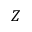<formula> <loc_0><loc_0><loc_500><loc_500>Z</formula> 